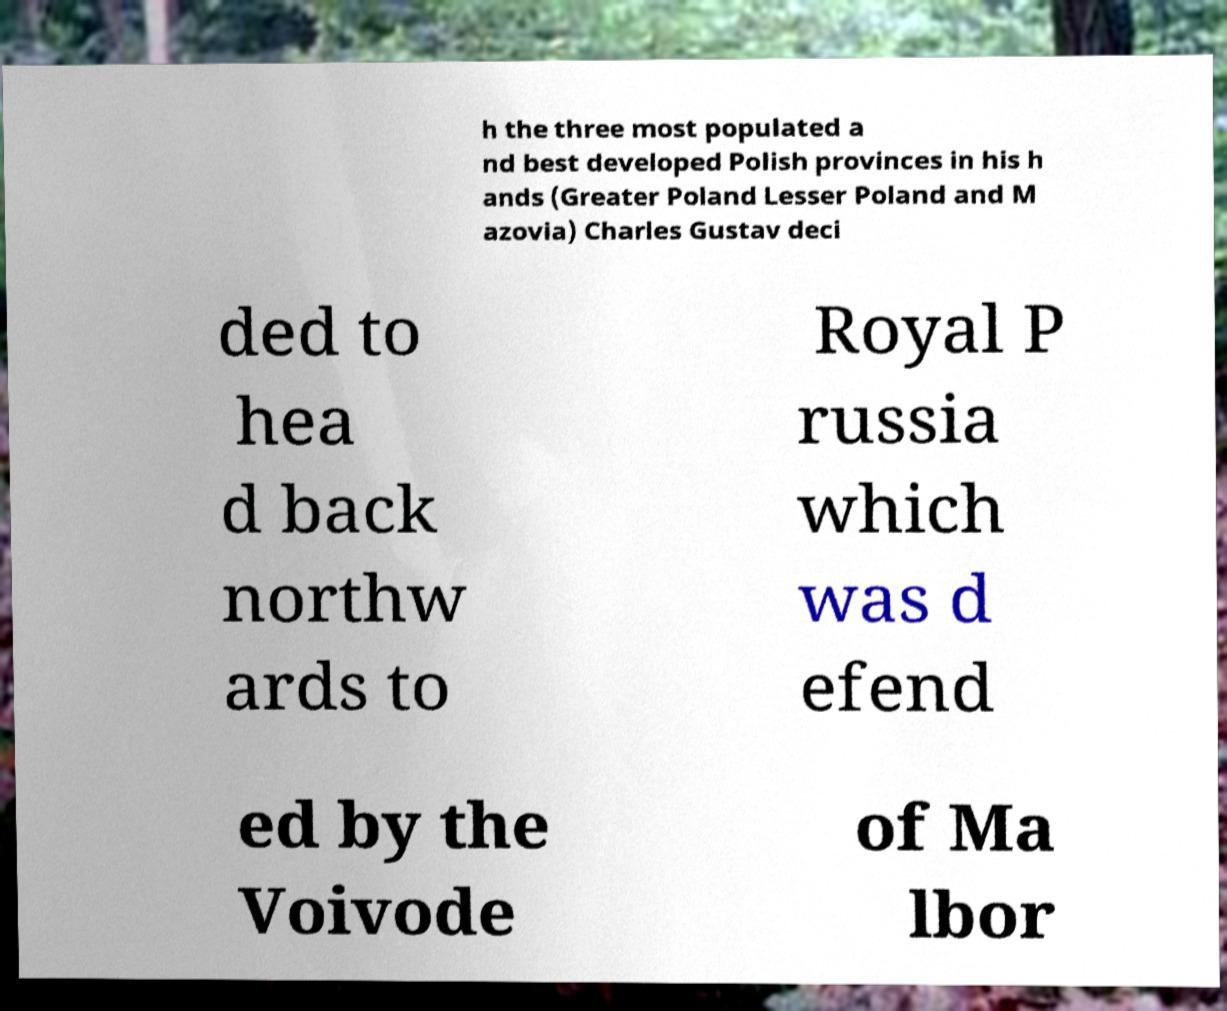Can you read and provide the text displayed in the image?This photo seems to have some interesting text. Can you extract and type it out for me? h the three most populated a nd best developed Polish provinces in his h ands (Greater Poland Lesser Poland and M azovia) Charles Gustav deci ded to hea d back northw ards to Royal P russia which was d efend ed by the Voivode of Ma lbor 